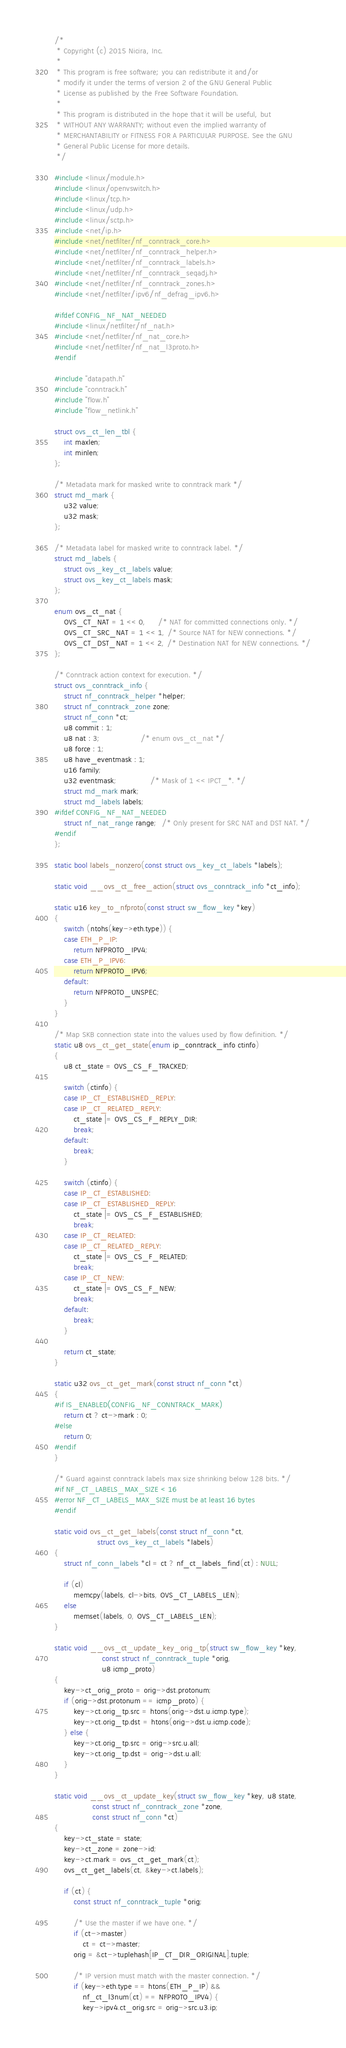<code> <loc_0><loc_0><loc_500><loc_500><_C_>/*
 * Copyright (c) 2015 Nicira, Inc.
 *
 * This program is free software; you can redistribute it and/or
 * modify it under the terms of version 2 of the GNU General Public
 * License as published by the Free Software Foundation.
 *
 * This program is distributed in the hope that it will be useful, but
 * WITHOUT ANY WARRANTY; without even the implied warranty of
 * MERCHANTABILITY or FITNESS FOR A PARTICULAR PURPOSE. See the GNU
 * General Public License for more details.
 */

#include <linux/module.h>
#include <linux/openvswitch.h>
#include <linux/tcp.h>
#include <linux/udp.h>
#include <linux/sctp.h>
#include <net/ip.h>
#include <net/netfilter/nf_conntrack_core.h>
#include <net/netfilter/nf_conntrack_helper.h>
#include <net/netfilter/nf_conntrack_labels.h>
#include <net/netfilter/nf_conntrack_seqadj.h>
#include <net/netfilter/nf_conntrack_zones.h>
#include <net/netfilter/ipv6/nf_defrag_ipv6.h>

#ifdef CONFIG_NF_NAT_NEEDED
#include <linux/netfilter/nf_nat.h>
#include <net/netfilter/nf_nat_core.h>
#include <net/netfilter/nf_nat_l3proto.h>
#endif

#include "datapath.h"
#include "conntrack.h"
#include "flow.h"
#include "flow_netlink.h"

struct ovs_ct_len_tbl {
	int maxlen;
	int minlen;
};

/* Metadata mark for masked write to conntrack mark */
struct md_mark {
	u32 value;
	u32 mask;
};

/* Metadata label for masked write to conntrack label. */
struct md_labels {
	struct ovs_key_ct_labels value;
	struct ovs_key_ct_labels mask;
};

enum ovs_ct_nat {
	OVS_CT_NAT = 1 << 0,     /* NAT for committed connections only. */
	OVS_CT_SRC_NAT = 1 << 1, /* Source NAT for NEW connections. */
	OVS_CT_DST_NAT = 1 << 2, /* Destination NAT for NEW connections. */
};

/* Conntrack action context for execution. */
struct ovs_conntrack_info {
	struct nf_conntrack_helper *helper;
	struct nf_conntrack_zone zone;
	struct nf_conn *ct;
	u8 commit : 1;
	u8 nat : 3;                 /* enum ovs_ct_nat */
	u8 force : 1;
	u8 have_eventmask : 1;
	u16 family;
	u32 eventmask;              /* Mask of 1 << IPCT_*. */
	struct md_mark mark;
	struct md_labels labels;
#ifdef CONFIG_NF_NAT_NEEDED
	struct nf_nat_range range;  /* Only present for SRC NAT and DST NAT. */
#endif
};

static bool labels_nonzero(const struct ovs_key_ct_labels *labels);

static void __ovs_ct_free_action(struct ovs_conntrack_info *ct_info);

static u16 key_to_nfproto(const struct sw_flow_key *key)
{
	switch (ntohs(key->eth.type)) {
	case ETH_P_IP:
		return NFPROTO_IPV4;
	case ETH_P_IPV6:
		return NFPROTO_IPV6;
	default:
		return NFPROTO_UNSPEC;
	}
}

/* Map SKB connection state into the values used by flow definition. */
static u8 ovs_ct_get_state(enum ip_conntrack_info ctinfo)
{
	u8 ct_state = OVS_CS_F_TRACKED;

	switch (ctinfo) {
	case IP_CT_ESTABLISHED_REPLY:
	case IP_CT_RELATED_REPLY:
		ct_state |= OVS_CS_F_REPLY_DIR;
		break;
	default:
		break;
	}

	switch (ctinfo) {
	case IP_CT_ESTABLISHED:
	case IP_CT_ESTABLISHED_REPLY:
		ct_state |= OVS_CS_F_ESTABLISHED;
		break;
	case IP_CT_RELATED:
	case IP_CT_RELATED_REPLY:
		ct_state |= OVS_CS_F_RELATED;
		break;
	case IP_CT_NEW:
		ct_state |= OVS_CS_F_NEW;
		break;
	default:
		break;
	}

	return ct_state;
}

static u32 ovs_ct_get_mark(const struct nf_conn *ct)
{
#if IS_ENABLED(CONFIG_NF_CONNTRACK_MARK)
	return ct ? ct->mark : 0;
#else
	return 0;
#endif
}

/* Guard against conntrack labels max size shrinking below 128 bits. */
#if NF_CT_LABELS_MAX_SIZE < 16
#error NF_CT_LABELS_MAX_SIZE must be at least 16 bytes
#endif

static void ovs_ct_get_labels(const struct nf_conn *ct,
			      struct ovs_key_ct_labels *labels)
{
	struct nf_conn_labels *cl = ct ? nf_ct_labels_find(ct) : NULL;

	if (cl)
		memcpy(labels, cl->bits, OVS_CT_LABELS_LEN);
	else
		memset(labels, 0, OVS_CT_LABELS_LEN);
}

static void __ovs_ct_update_key_orig_tp(struct sw_flow_key *key,
					const struct nf_conntrack_tuple *orig,
					u8 icmp_proto)
{
	key->ct_orig_proto = orig->dst.protonum;
	if (orig->dst.protonum == icmp_proto) {
		key->ct.orig_tp.src = htons(orig->dst.u.icmp.type);
		key->ct.orig_tp.dst = htons(orig->dst.u.icmp.code);
	} else {
		key->ct.orig_tp.src = orig->src.u.all;
		key->ct.orig_tp.dst = orig->dst.u.all;
	}
}

static void __ovs_ct_update_key(struct sw_flow_key *key, u8 state,
				const struct nf_conntrack_zone *zone,
				const struct nf_conn *ct)
{
	key->ct_state = state;
	key->ct_zone = zone->id;
	key->ct.mark = ovs_ct_get_mark(ct);
	ovs_ct_get_labels(ct, &key->ct.labels);

	if (ct) {
		const struct nf_conntrack_tuple *orig;

		/* Use the master if we have one. */
		if (ct->master)
			ct = ct->master;
		orig = &ct->tuplehash[IP_CT_DIR_ORIGINAL].tuple;

		/* IP version must match with the master connection. */
		if (key->eth.type == htons(ETH_P_IP) &&
		    nf_ct_l3num(ct) == NFPROTO_IPV4) {
			key->ipv4.ct_orig.src = orig->src.u3.ip;</code> 